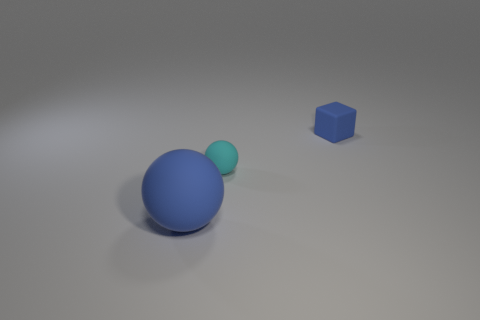Are there an equal number of cubes that are in front of the big rubber object and large brown matte cylinders?
Provide a succinct answer. Yes. Does the blue matte cube have the same size as the blue thing left of the small blue cube?
Your response must be concise. No. There is a tiny matte thing in front of the rubber cube; what is its shape?
Your answer should be compact. Sphere. Are there any other things that have the same shape as the small blue thing?
Give a very brief answer. No. Are there any small blue matte things?
Your answer should be very brief. Yes. Does the blue rubber thing that is behind the cyan rubber ball have the same size as the blue object on the left side of the rubber block?
Offer a very short reply. No. What number of blue things are behind the tiny cyan rubber sphere?
Ensure brevity in your answer.  1. Is there anything else that is the same size as the blue rubber sphere?
Give a very brief answer. No. There is a big object that is the same material as the blue block; what color is it?
Provide a succinct answer. Blue. Is the shape of the cyan thing the same as the tiny blue thing?
Make the answer very short. No. 